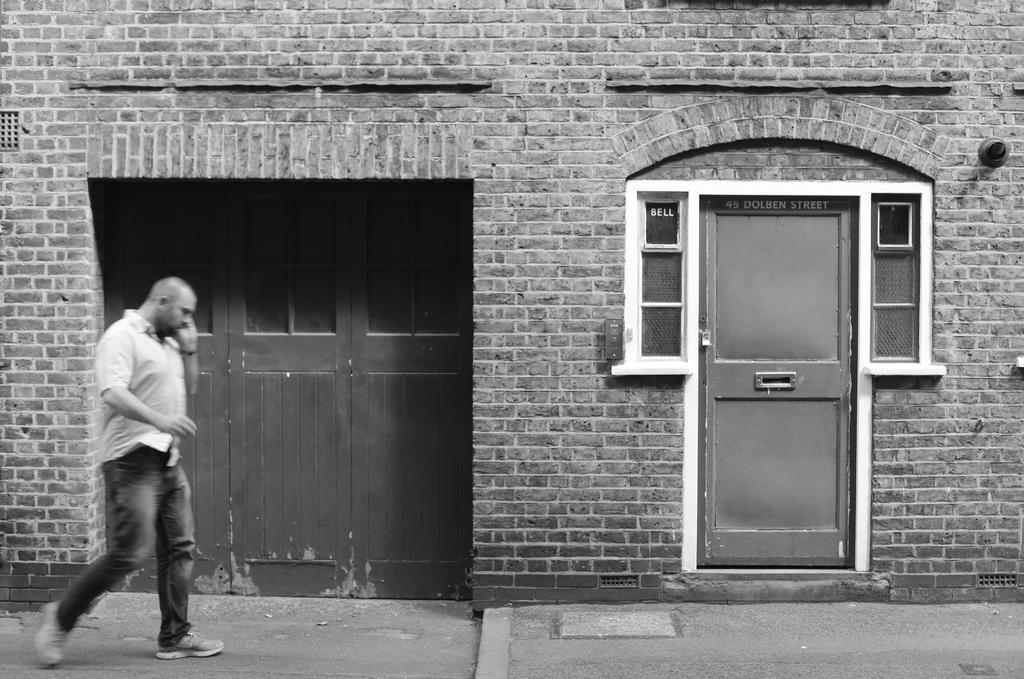What is the main subject of the image? There is a person walking in the center of the image. What can be seen in the background of the image? There is a house and doors visible in the background. What is written on the wall of the building? There is text written on the wall of the building. What type of silver pin is the grandfather wearing in the image? There is no grandfather or silver pin present in the image. 